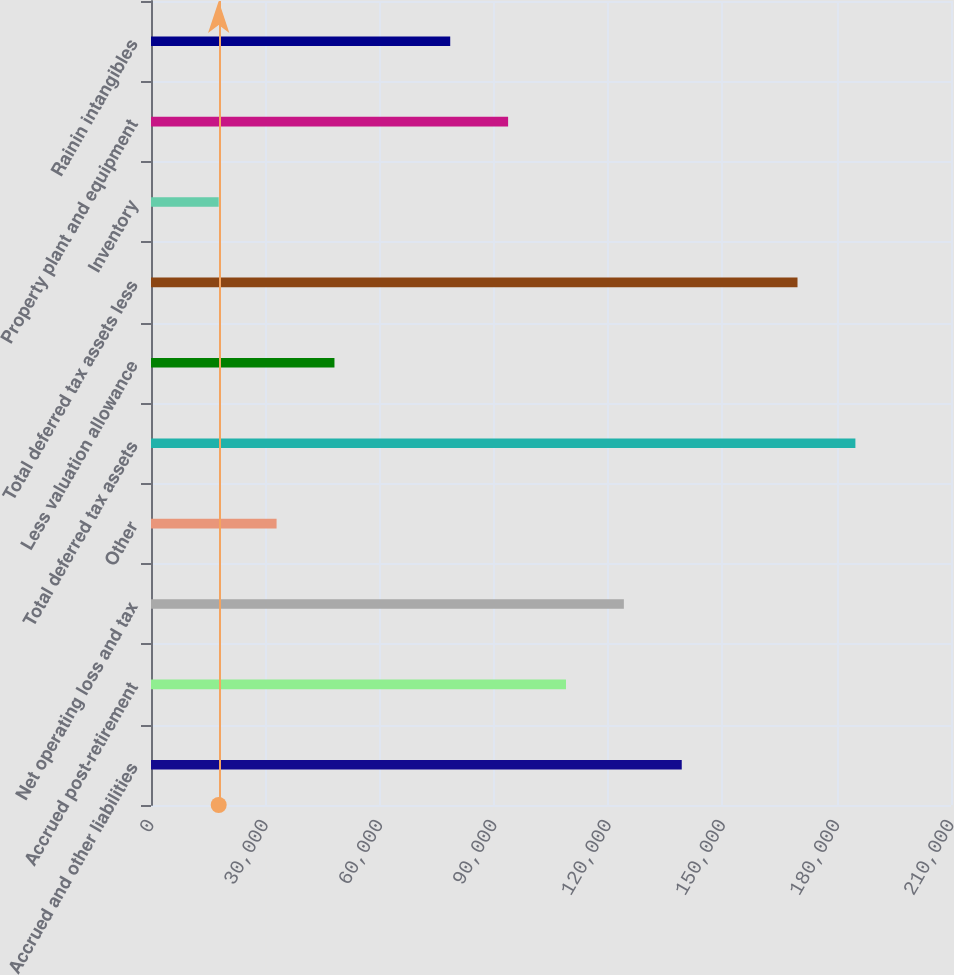Convert chart to OTSL. <chart><loc_0><loc_0><loc_500><loc_500><bar_chart><fcel>Accrued and other liabilities<fcel>Accrued post-retirement<fcel>Net operating loss and tax<fcel>Other<fcel>Total deferred tax assets<fcel>Less valuation allowance<fcel>Total deferred tax assets less<fcel>Inventory<fcel>Property plant and equipment<fcel>Rainin intangibles<nl><fcel>139321<fcel>108934<fcel>124127<fcel>32964.6<fcel>184903<fcel>48158.4<fcel>169709<fcel>17770.8<fcel>93739.8<fcel>78546<nl></chart> 